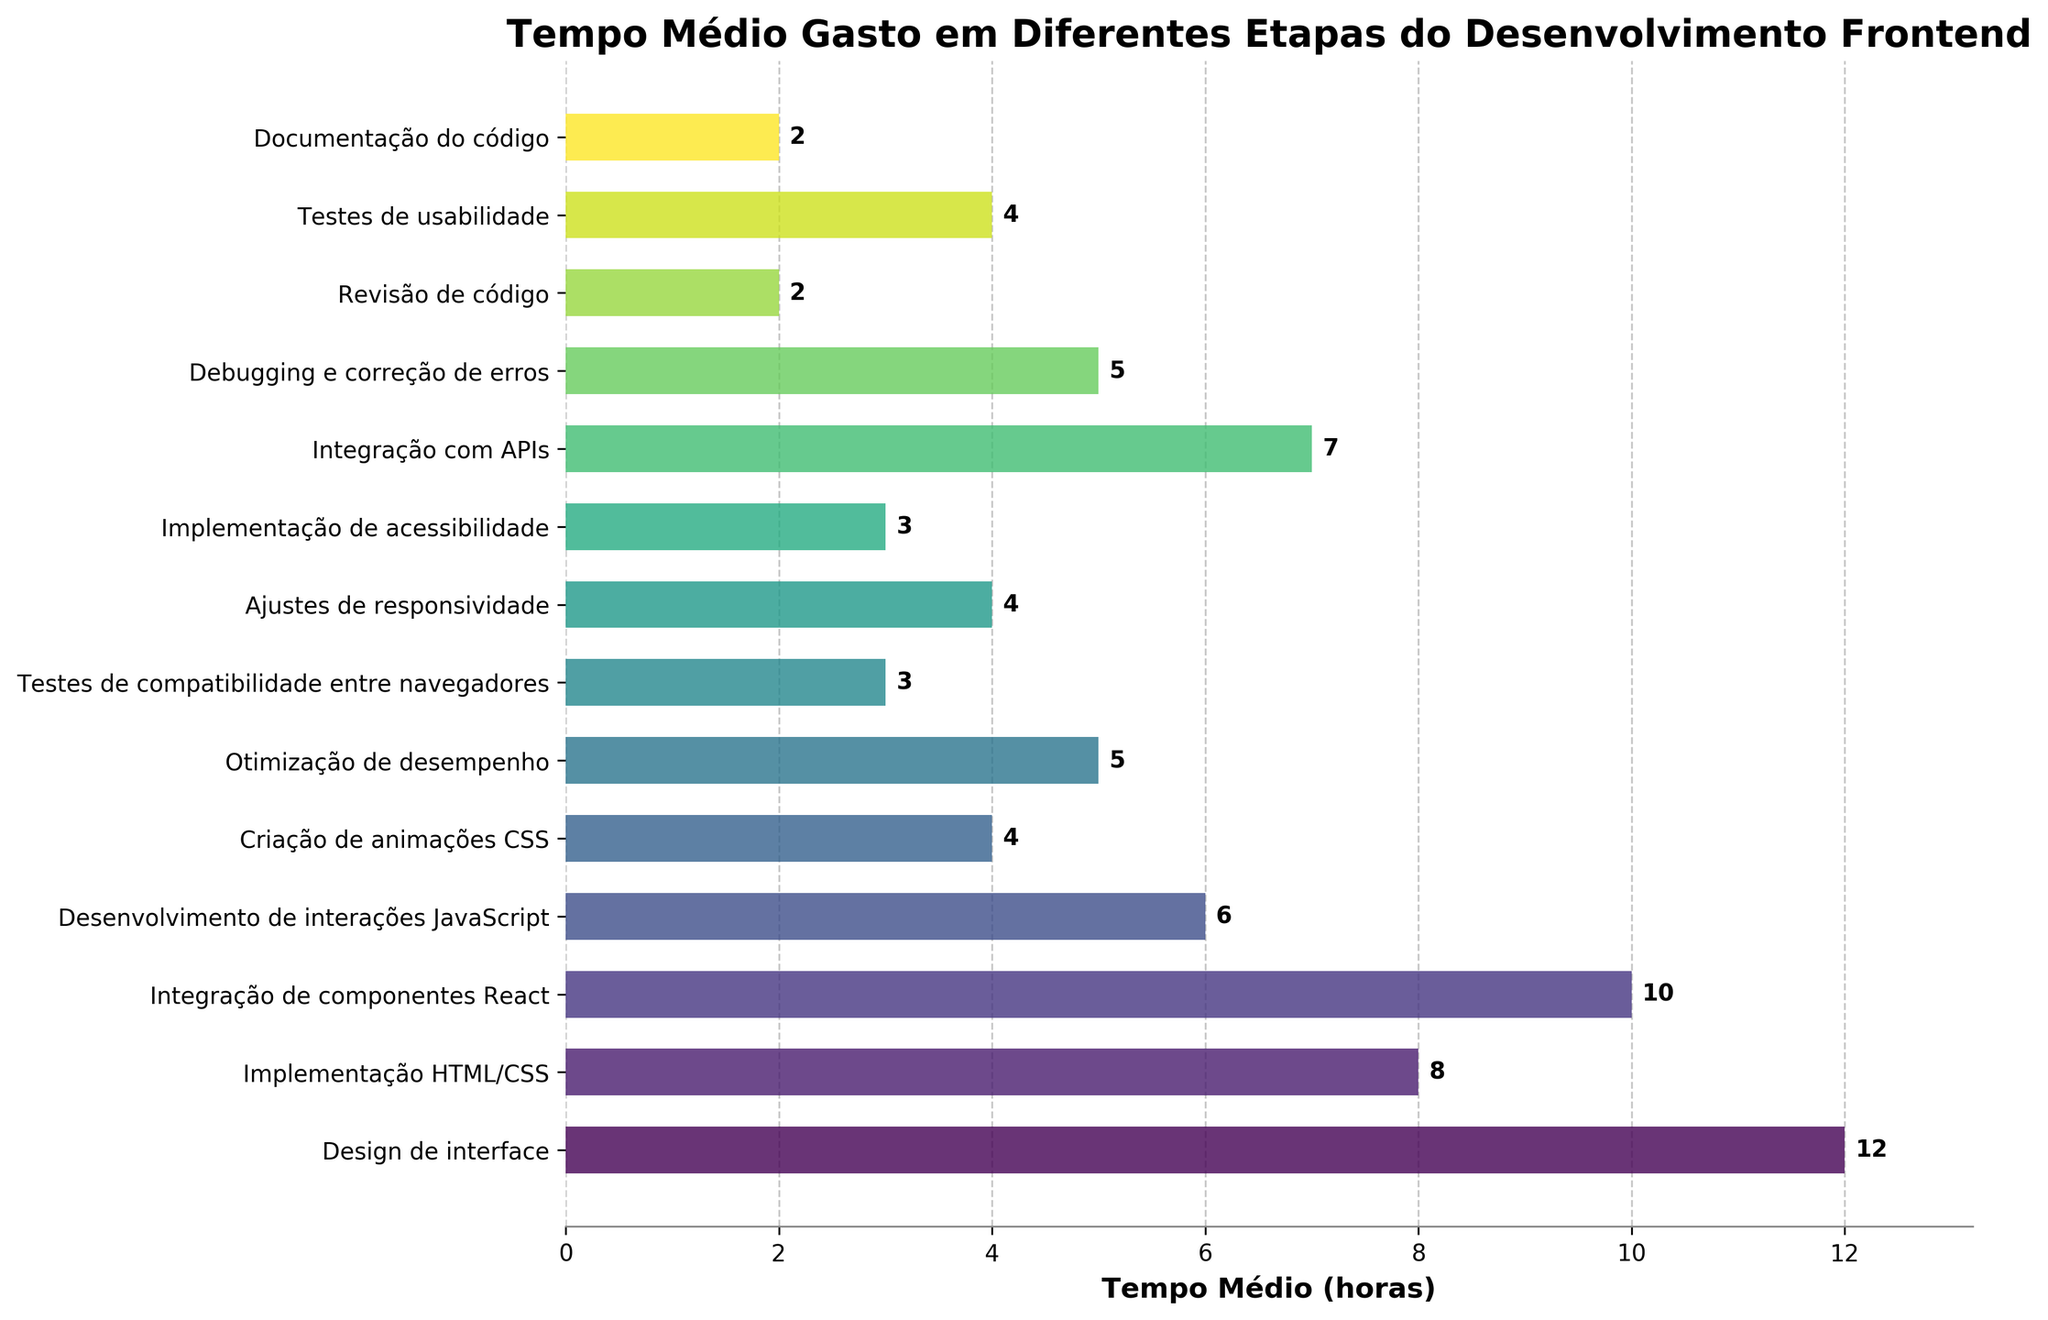Qual etapa do desenvolvimento frontend leva mais tempo? Observe os comprimentos das barras horizontais no gráfico. A barra mais longa representa o "Design de interface", que gasta 12 horas.
Answer: Design de interface Qual a diferença de tempo médio entre Implementação HTML/CSS e Integração de componentes React? Localize as duas barras correspondentes no gráfico e subtraia os tempos. Integração de componentes React (10 horas) menos Implementação HTML/CSS (8 horas) é igual a 2 horas.
Answer: 2 horas Quais etapas têm tempos médios iguais? Verifique todas as barras no gráfico e procure por valores idênticos. Três combinações têm tempos iguais: Testes de compatibilidade entre navegadores e Implementação de acessibilidade (3 horas), Criação de animações CSS e Ajustes de responsividade e Testes de usabilidade (4 horas), Debugging e correção de erros e Otimização de desempenho (5 horas), Revisão de código e Documentação do código (2 horas).
Answer: Várias etapas têm tempos iguais Qual etapa consome menos tempo? Identifique a barra mais curta no gráfico. A menor barra corresponde à "Revisão de código e Documentação do código", que gasta 2 horas.
Answer: Revisão de código Qual a soma do tempo médio gasto em Desenvolvimento de interações JavaScript e Criação de animações CSS? Some os tempos das duas etapas. Desenvolvimento de interações JavaScript (6 horas) + Criação de animações CSS (4 horas) = 10 horas.
Answer: 10 horas Se você somar o tempo gasto em Otimização de desempenho e Integração com APIs, quanto tempo você terá? Some os tempos das duas etapas. Otimização de desempenho (5 horas) + Integração com APIs (7 horas) = 12 horas.
Answer: 12 horas Qual percentual do tempo total é gasto em Testes de usabilidade? Calcule a soma de todos os tempos, depois ache a fração correspondente ao tempo de Testes de usabilidade e multiplique por 100 para obter o percentual. Tempo total é 71 horas, tempo de Testes de usabilidade é 4 horas. (4 / 71) * 100 ≈ 5.63%.
Answer: 5.63% A barra representando Integração com APIs tem uma cor mais escura ou mais clara que a barra representando Debugging e correção de erros? No colormap viridis, cores mais escuras aparecem em etapas mais abaixo na lista. Debugging e correção de erros tem um valor mais brilhante que Integração com APIs.
Answer: Mais escura Qual sequência de duas etapas adjacentes tem a maior diferença de tempo médio gasto? Primeiro, calcule a diferença de tempo médio gasto entre cada etapa adjacente. A maior diferença é entre Design de interface (12 horas) e Integração de componentes React (10 horas), com uma diferença de 4 horas.
Answer: Design de interface e Integração de componentes React 